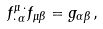Convert formula to latex. <formula><loc_0><loc_0><loc_500><loc_500>f ^ { \mu \, \cdot } _ { \cdot \, \alpha } f _ { \mu \beta } = g _ { \alpha \beta } \, ,</formula> 